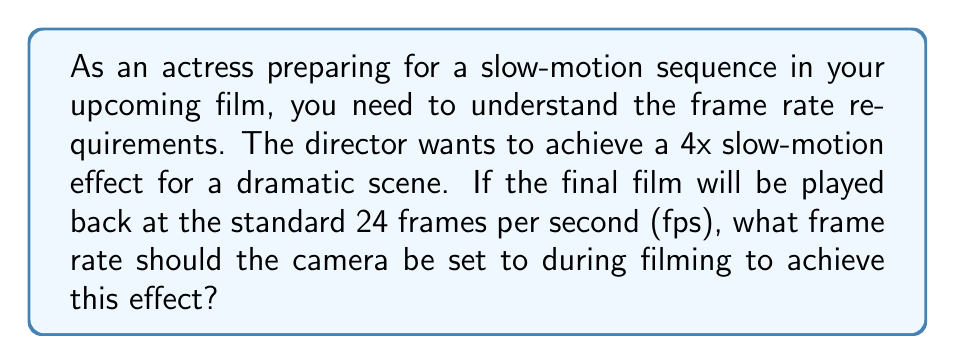What is the answer to this math problem? To solve this problem, we need to understand the relationship between the filming frame rate, playback frame rate, and the desired slow-motion effect:

1. The standard playback rate is 24 fps.
2. We want to achieve a 4x slow-motion effect.

To create a slow-motion effect, we need to film at a higher frame rate than the playback rate. The relationship can be expressed as:

$$ \text{Filming frame rate} = \text{Playback frame rate} \times \text{Slow-motion factor} $$

In this case:
$$ \text{Filming frame rate} = 24 \text{ fps} \times 4 $$

Calculating:
$$ \text{Filming frame rate} = 96 \text{ fps} $$

This means that for every second of playback time, we need to capture 96 frames during filming. When these 96 frames are played back at 24 fps, they will take 4 seconds to display, creating the desired 4x slow-motion effect.

To verify:
$$ \frac{\text{Filming frame rate}}{\text{Playback frame rate}} = \frac{96 \text{ fps}}{24 \text{ fps}} = 4 $$

This ratio confirms that we will achieve the 4x slow-motion effect.
Answer: The camera should be set to 96 fps during filming to achieve a 4x slow-motion effect when played back at 24 fps. 